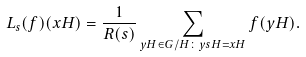Convert formula to latex. <formula><loc_0><loc_0><loc_500><loc_500>L _ { s } ( f ) ( x H ) = \frac { 1 } { R ( s ) } \sum _ { y H \in G / H \colon y s H = x H } f ( y H ) .</formula> 